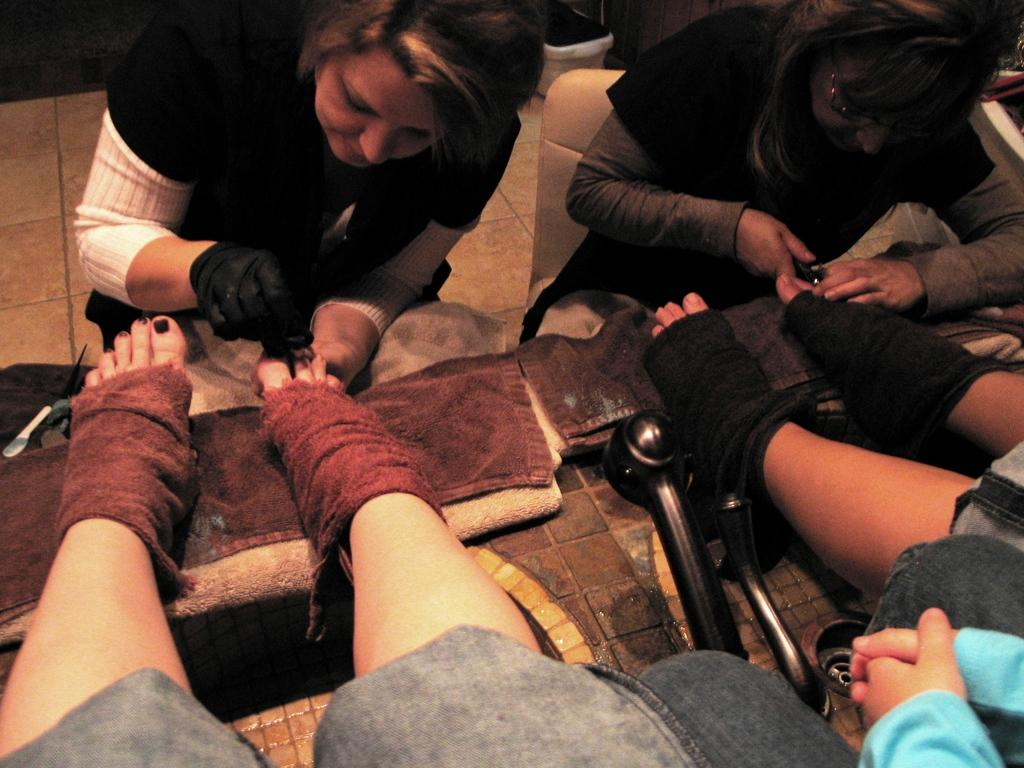What is visible in the foreground of the picture? There are two persons' legs in the foreground of the picture. What is the surface on which the legs are placed? The legs are on a cloth. What can be seen at the top of the image? There are two women sitting in chairs at the top of the image. What type of receipt can be seen in the hands of the women in the image? There is no receipt visible in the image; the women are sitting in chairs without any visible objects in their hands. 